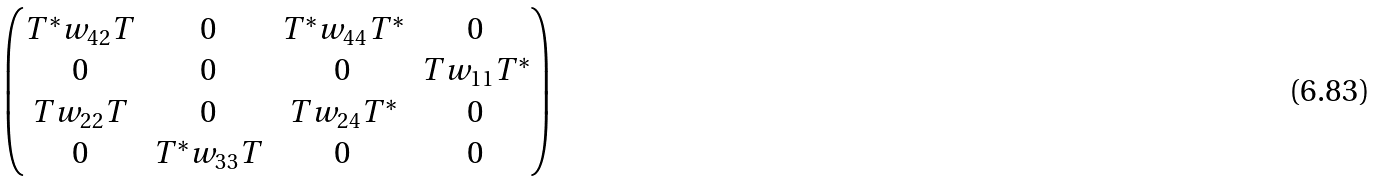<formula> <loc_0><loc_0><loc_500><loc_500>\begin{pmatrix} T ^ { * } w _ { 4 2 } T & 0 & T ^ { * } w _ { 4 4 } T ^ { * } & 0 \\ 0 & 0 & 0 & T w _ { 1 1 } T ^ { * } \\ T w _ { 2 2 } T & 0 & T w _ { 2 4 } T ^ { * } & 0 \\ 0 & T ^ { * } w _ { 3 3 } T & 0 & 0 \end{pmatrix}</formula> 